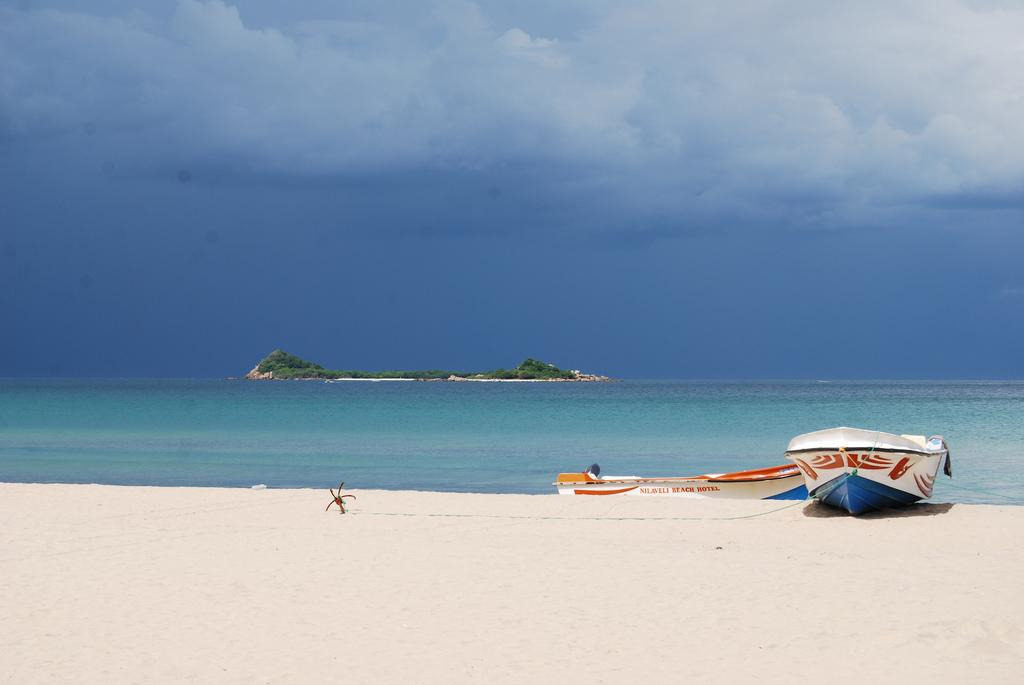What type of vehicles can be seen on the right side of the image? There are boats on the right side of the image. What natural element is visible in the image? There is water visible in the image. What type of vegetation is present in the image? There are trees in the image. What type of terrain can be seen in the image? There is sand in the image. What is visible in the sky in the image? Clouds are visible in the sky. What type of rice is being cooked in the image? There is no rice present in the image. Can you see the mother walking on the trail in the image? There is no trail or mother present in the image. 